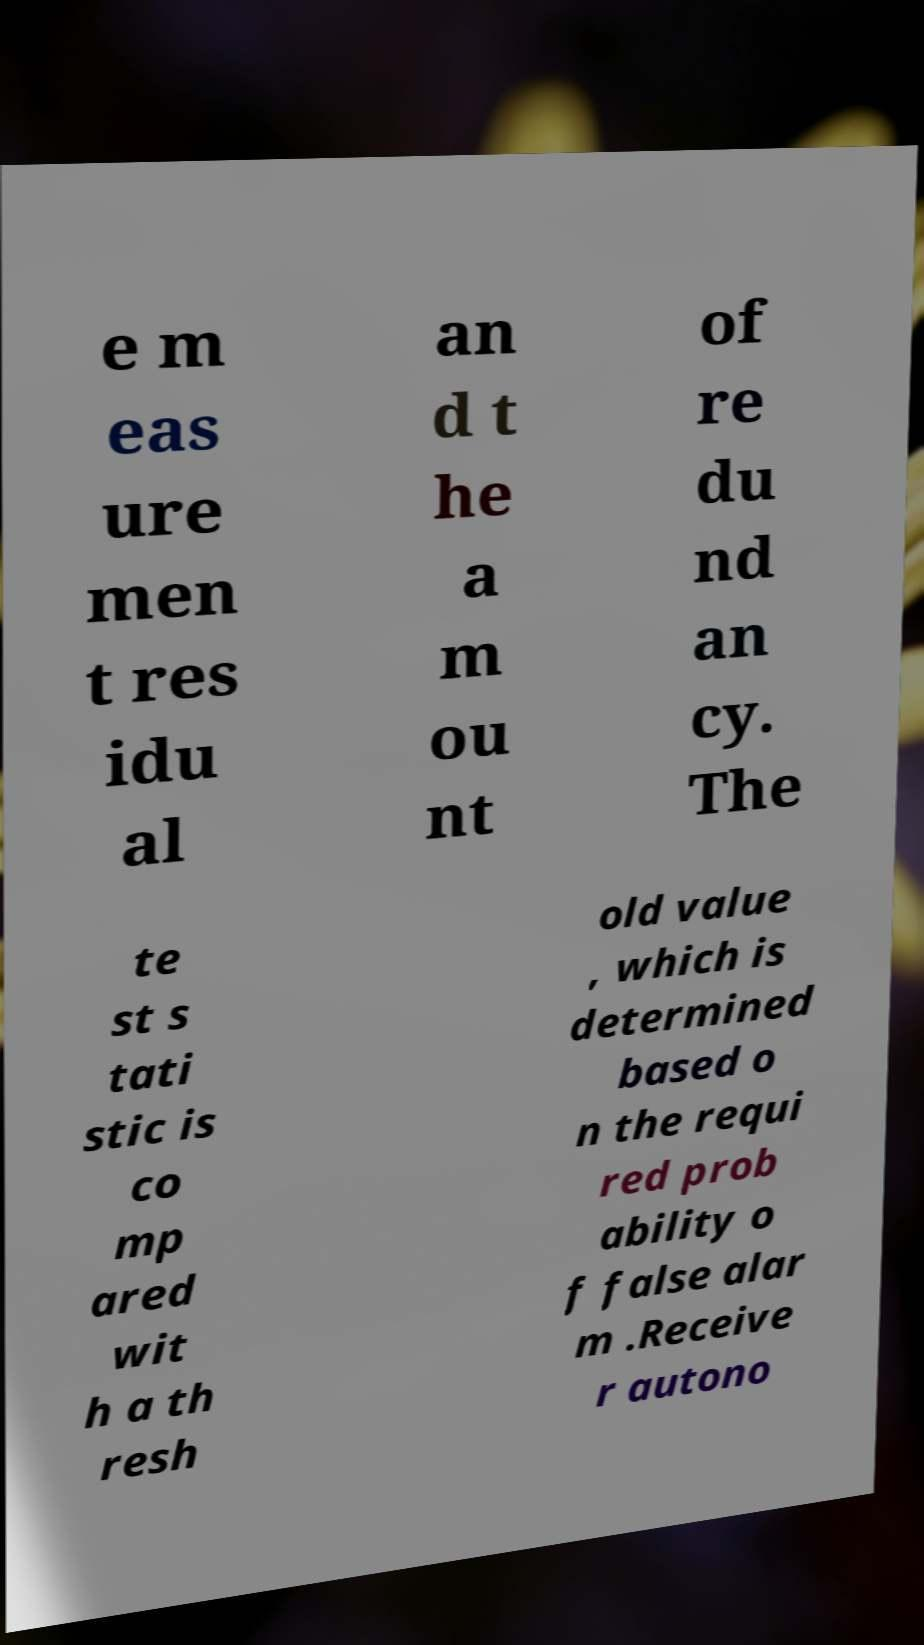Could you assist in decoding the text presented in this image and type it out clearly? e m eas ure men t res idu al an d t he a m ou nt of re du nd an cy. The te st s tati stic is co mp ared wit h a th resh old value , which is determined based o n the requi red prob ability o f false alar m .Receive r autono 